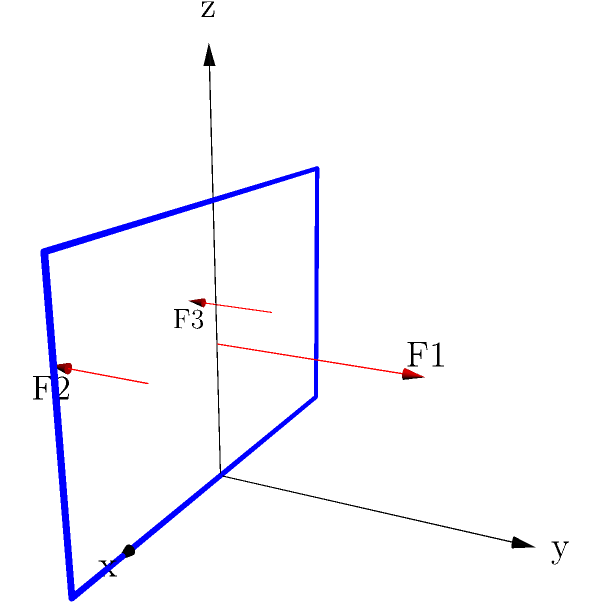A bridge is modeled in a 3D coordinate system as shown in the diagram. Three force vectors are applied to the bridge: $F_1 = (0, 100, 0)$ kN, $F_2 = (-50, -50, 0)$ kN, and $F_3 = (50, -50, 0)$ kN. Calculate the magnitude of the resultant force vector acting on the bridge structure. To solve this problem, we'll follow these steps:

1) First, we need to sum up all the force vectors to get the resultant force vector:

   $F_{resultant} = F_1 + F_2 + F_3$

2) Let's add the components of each force vector:
   
   x-component: $0 + (-50) + 50 = 0$ kN
   y-component: $100 + (-50) + (-50) = 0$ kN
   z-component: $0 + 0 + 0 = 0$ kN

3) So, the resultant force vector is:

   $F_{resultant} = (0, 0, 0)$ kN

4) To calculate the magnitude of this vector, we use the formula:

   $|F_{resultant}| = \sqrt{x^2 + y^2 + z^2}$

5) Substituting our values:

   $|F_{resultant}| = \sqrt{0^2 + 0^2 + 0^2} = 0$ kN

Therefore, the magnitude of the resultant force vector is 0 kN. This means that the forces are in equilibrium, and there is no net force acting on the bridge structure.
Answer: 0 kN 